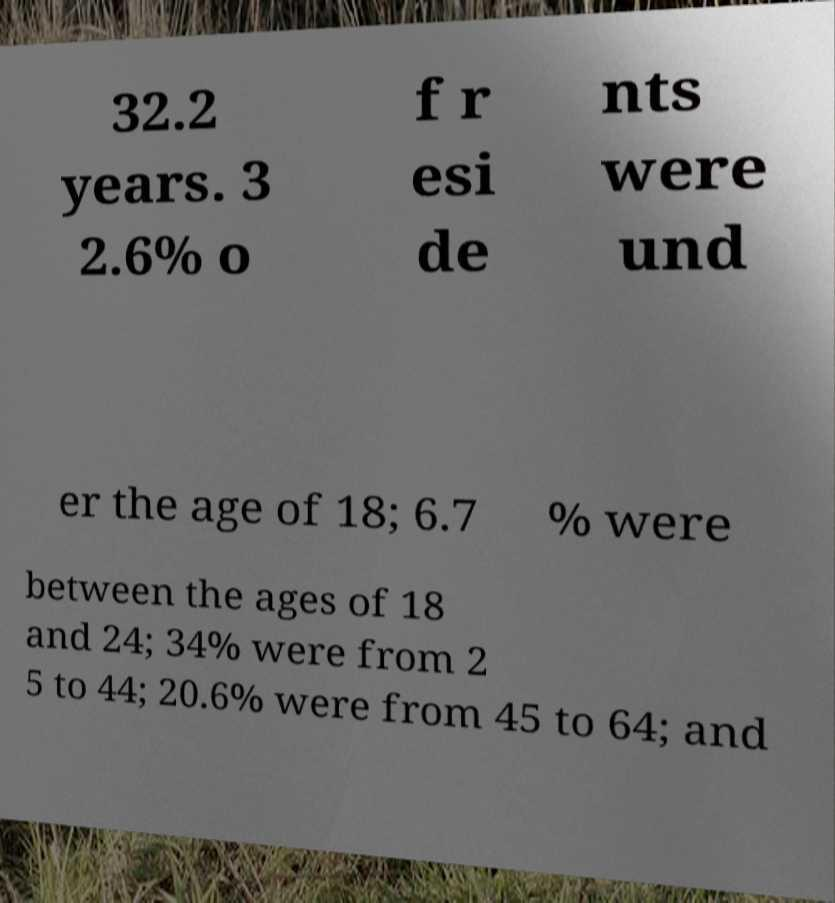What messages or text are displayed in this image? I need them in a readable, typed format. 32.2 years. 3 2.6% o f r esi de nts were und er the age of 18; 6.7 % were between the ages of 18 and 24; 34% were from 2 5 to 44; 20.6% were from 45 to 64; and 